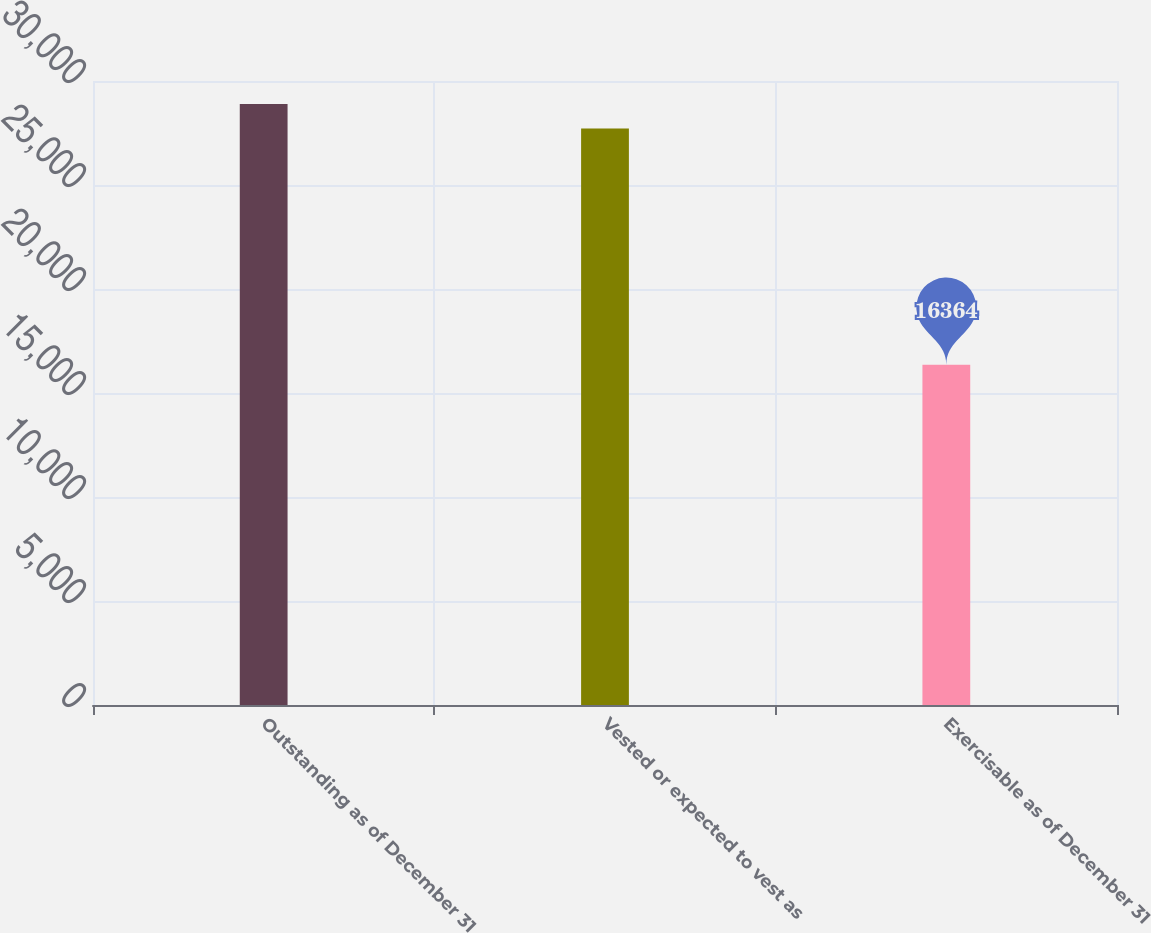<chart> <loc_0><loc_0><loc_500><loc_500><bar_chart><fcel>Outstanding as of December 31<fcel>Vested or expected to vest as<fcel>Exercisable as of December 31<nl><fcel>28896.4<fcel>27712<fcel>16364<nl></chart> 